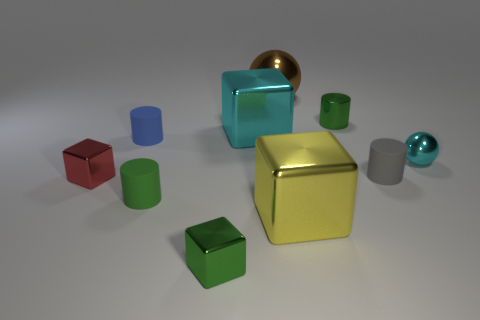Is there any other thing that has the same size as the red metallic object?
Keep it short and to the point. Yes. There is a small shiny cylinder; is it the same color as the block that is in front of the yellow metallic block?
Offer a very short reply. Yes. There is a tiny metallic object that is in front of the red cube; is it the same color as the metal cylinder?
Offer a very short reply. Yes. There is a cube that is the same color as the tiny metallic sphere; what size is it?
Offer a terse response. Large. There is a green cylinder on the right side of the cyan metal object to the left of the big brown shiny object; how many big cyan metallic blocks are behind it?
Give a very brief answer. 0. Is there a large metal thing that has the same color as the small shiny ball?
Ensure brevity in your answer.  Yes. The metal sphere that is the same size as the red block is what color?
Your answer should be compact. Cyan. Are there any large purple shiny objects that have the same shape as the tiny gray matte object?
Offer a very short reply. No. The large object that is the same color as the small sphere is what shape?
Your answer should be very brief. Cube. There is a metal sphere that is on the left side of the green object on the right side of the brown thing; are there any small rubber cylinders on the right side of it?
Provide a succinct answer. Yes. 